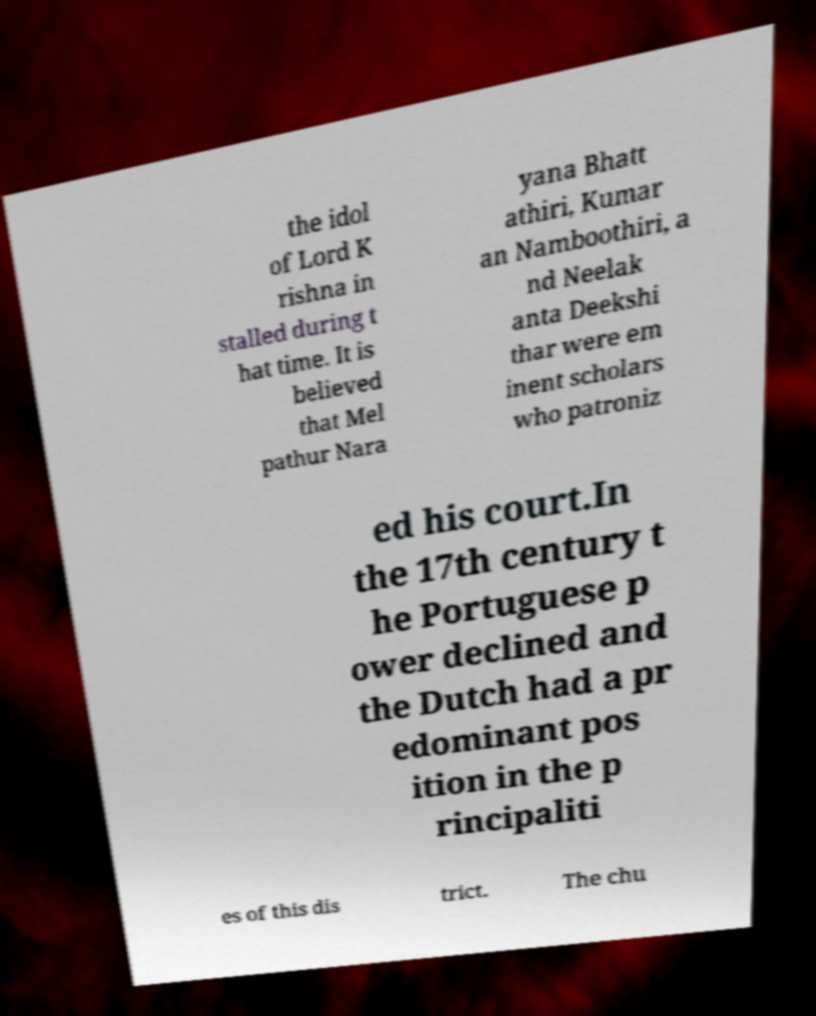Can you accurately transcribe the text from the provided image for me? the idol of Lord K rishna in stalled during t hat time. It is believed that Mel pathur Nara yana Bhatt athiri, Kumar an Namboothiri, a nd Neelak anta Deekshi thar were em inent scholars who patroniz ed his court.In the 17th century t he Portuguese p ower declined and the Dutch had a pr edominant pos ition in the p rincipaliti es of this dis trict. The chu 